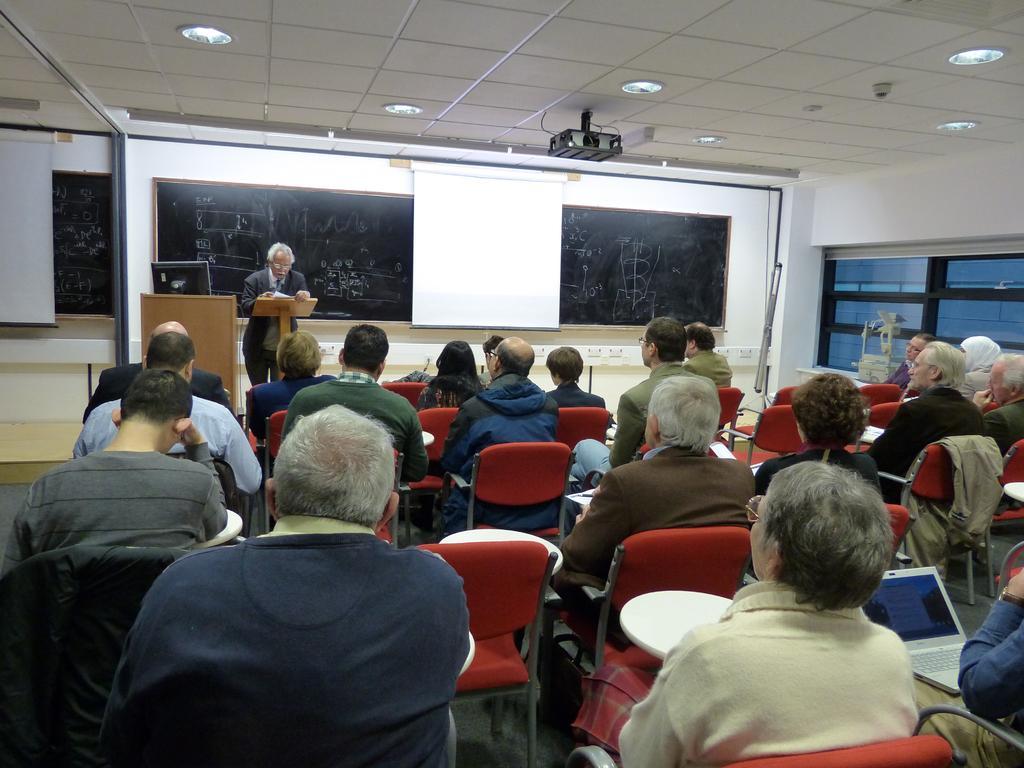How would you summarize this image in a sentence or two? In this image there are group of persons sitting. In the front on the right side there is laptop on the lap of the person and in the background there is a man standing and there is podium and on the podium there is a monitor and there are boards with some text on it. On the top there are lights and there is a projector. 